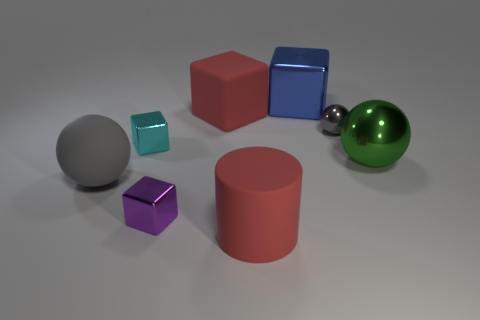There is a thing that is behind the big matte cylinder and in front of the big matte sphere; what is its color? The object located behind the big matte cylinder and in front of the big matte sphere is a small cube, which appears to be teal or turquoise in color. 